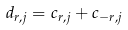<formula> <loc_0><loc_0><loc_500><loc_500>d _ { r , j } = c _ { r , j } + c _ { - r , j }</formula> 